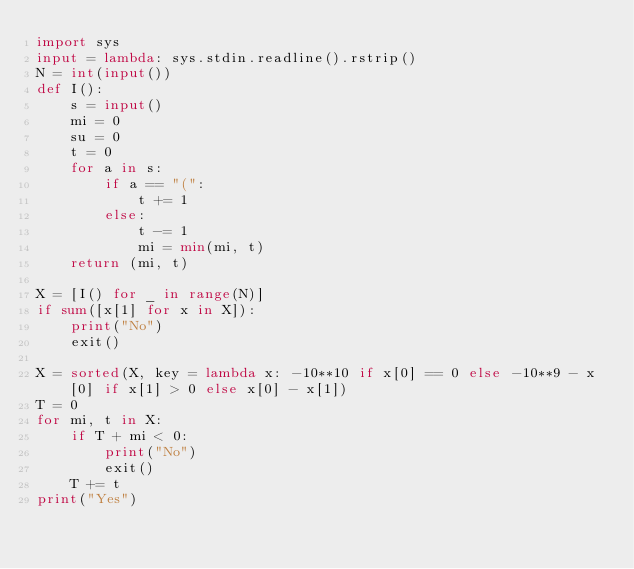<code> <loc_0><loc_0><loc_500><loc_500><_Python_>import sys
input = lambda: sys.stdin.readline().rstrip()
N = int(input())
def I():
    s = input()
    mi = 0
    su = 0
    t = 0
    for a in s:
        if a == "(":
            t += 1
        else:
            t -= 1
            mi = min(mi, t)
    return (mi, t)

X = [I() for _ in range(N)]
if sum([x[1] for x in X]):
    print("No")
    exit()

X = sorted(X, key = lambda x: -10**10 if x[0] == 0 else -10**9 - x[0] if x[1] > 0 else x[0] - x[1])
T = 0
for mi, t in X:
    if T + mi < 0:
        print("No")
        exit()
    T += t
print("Yes")</code> 